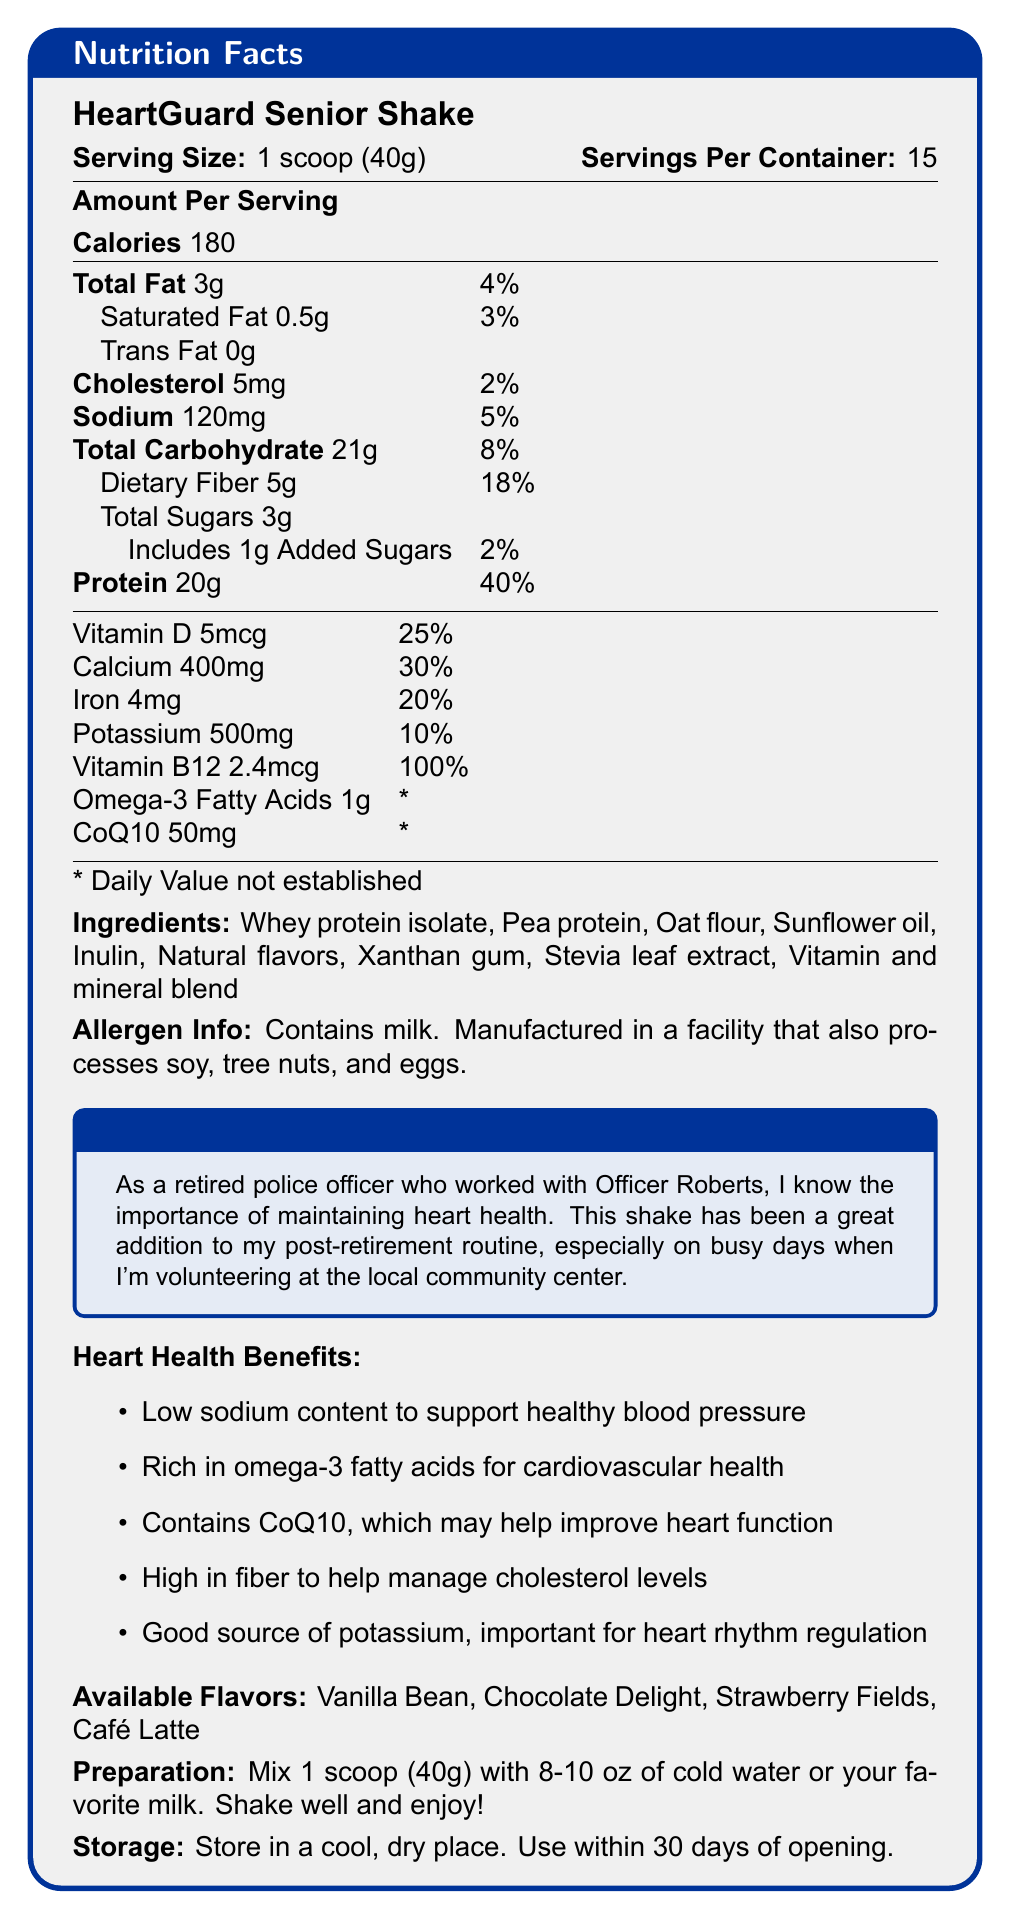what is the serving size for HeartGuard Senior Shake? The serving size is listed as "1 scoop (40g)" on the Nutrition Facts Label.
Answer: 1 scoop (40g) what is the sodium content per serving? The sodium content per serving is given as "120mg" on the Nutrition Facts Label.
Answer: 120mg how many servings are there per container? The number of servings per container is stated as "15" on the Nutrition Facts Label.
Answer: 15 which vitamin is provided at 100% of the daily value? Vitamin B12 is listed as providing 100% of the daily value on the Nutrition Facts Label.
Answer: Vitamin B12 what flavors are available for this shake? The available flavors are listed as "Vanilla Bean, Chocolate Delight, Strawberry Fields, Café Latte" at the end of the document.
Answer: Vanilla Bean, Chocolate Delight, Strawberry Fields, Café Latte how many grams of protein are in one serving? The protein content per serving is listed as "20g" on the Nutrition Facts Label.
Answer: 20g which heart health benefit is NOT mentioned? A. Supports healthy blood pressure B. Improves bone density C. Helps manage cholesterol levels D. Important for heart rhythm regulation The document does not mention improving bone density as a heart health benefit.
Answer: B. Improves bone density how much added sugar is in one serving? A. 0g B. 1g C. 3g D. 5g The added sugar content is stated as "1g" on the Nutrition Facts Label.
Answer: B. 1g what is the total carbohydrate content per serving? The total carbohydrate content per serving is listed as "21g" on the Nutrition Facts Label.
Answer: 21g is this product suitable for someone with a soy allergy? A. Yes B. No C. Not enough information The document states that the product contains milk and is manufactured in a facility that also processes soy. However, it does not specifically say if trace amounts of soy might be present.
Answer: C. Not enough information does the product contain any trans fat? The document states that the trans fat content is "0g."
Answer: No what specific ingredient helps improve heart function? The document mentions that CoQ10 may help improve heart function as one of the heart health benefits.
Answer: CoQ10 what is the main idea of the document? The document is designed to inform potential users about the nutritional contents and health benefits of the HeartGuard Senior Shake, with an emphasis on heart health for retirees. It includes serving details, nutritional breakdown, heart health benefits, flavors, preparation, and storage instructions.
Answer: The document provides comprehensive nutritional information for HeartGuard Senior Shake, highlighting its benefits for heart health, including low sodium content, high fiber, omega-3 fatty acids, and CoQ10. It also includes preparation and storage instructions. does the document mention the cost of the HeartGuard Senior Shake? The document does not provide any information about the cost of the HeartGuard Senior Shake.
Answer: No 